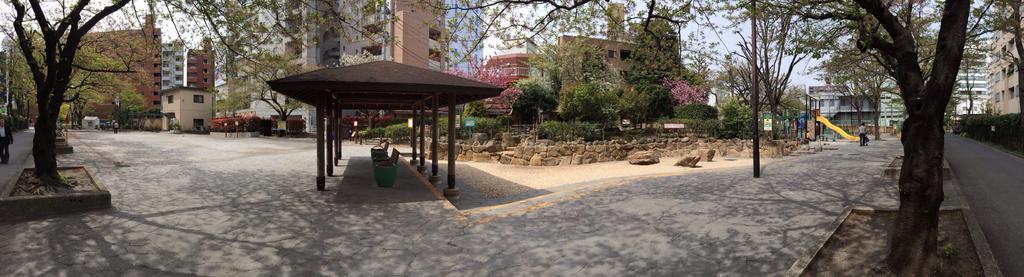Please provide a concise description of this image. In the center of the image we can see a shed with some pals, some chairs placed on the ground and some flowers on trees. On the right side of the image we can see some rocks, poles, a slide, sign board with some text, a group of plants and a person is holding a baby carrier. On the left side of the image we can see some people are standing. In the background, we can see buildings with windows, a group of trees and the sky. 